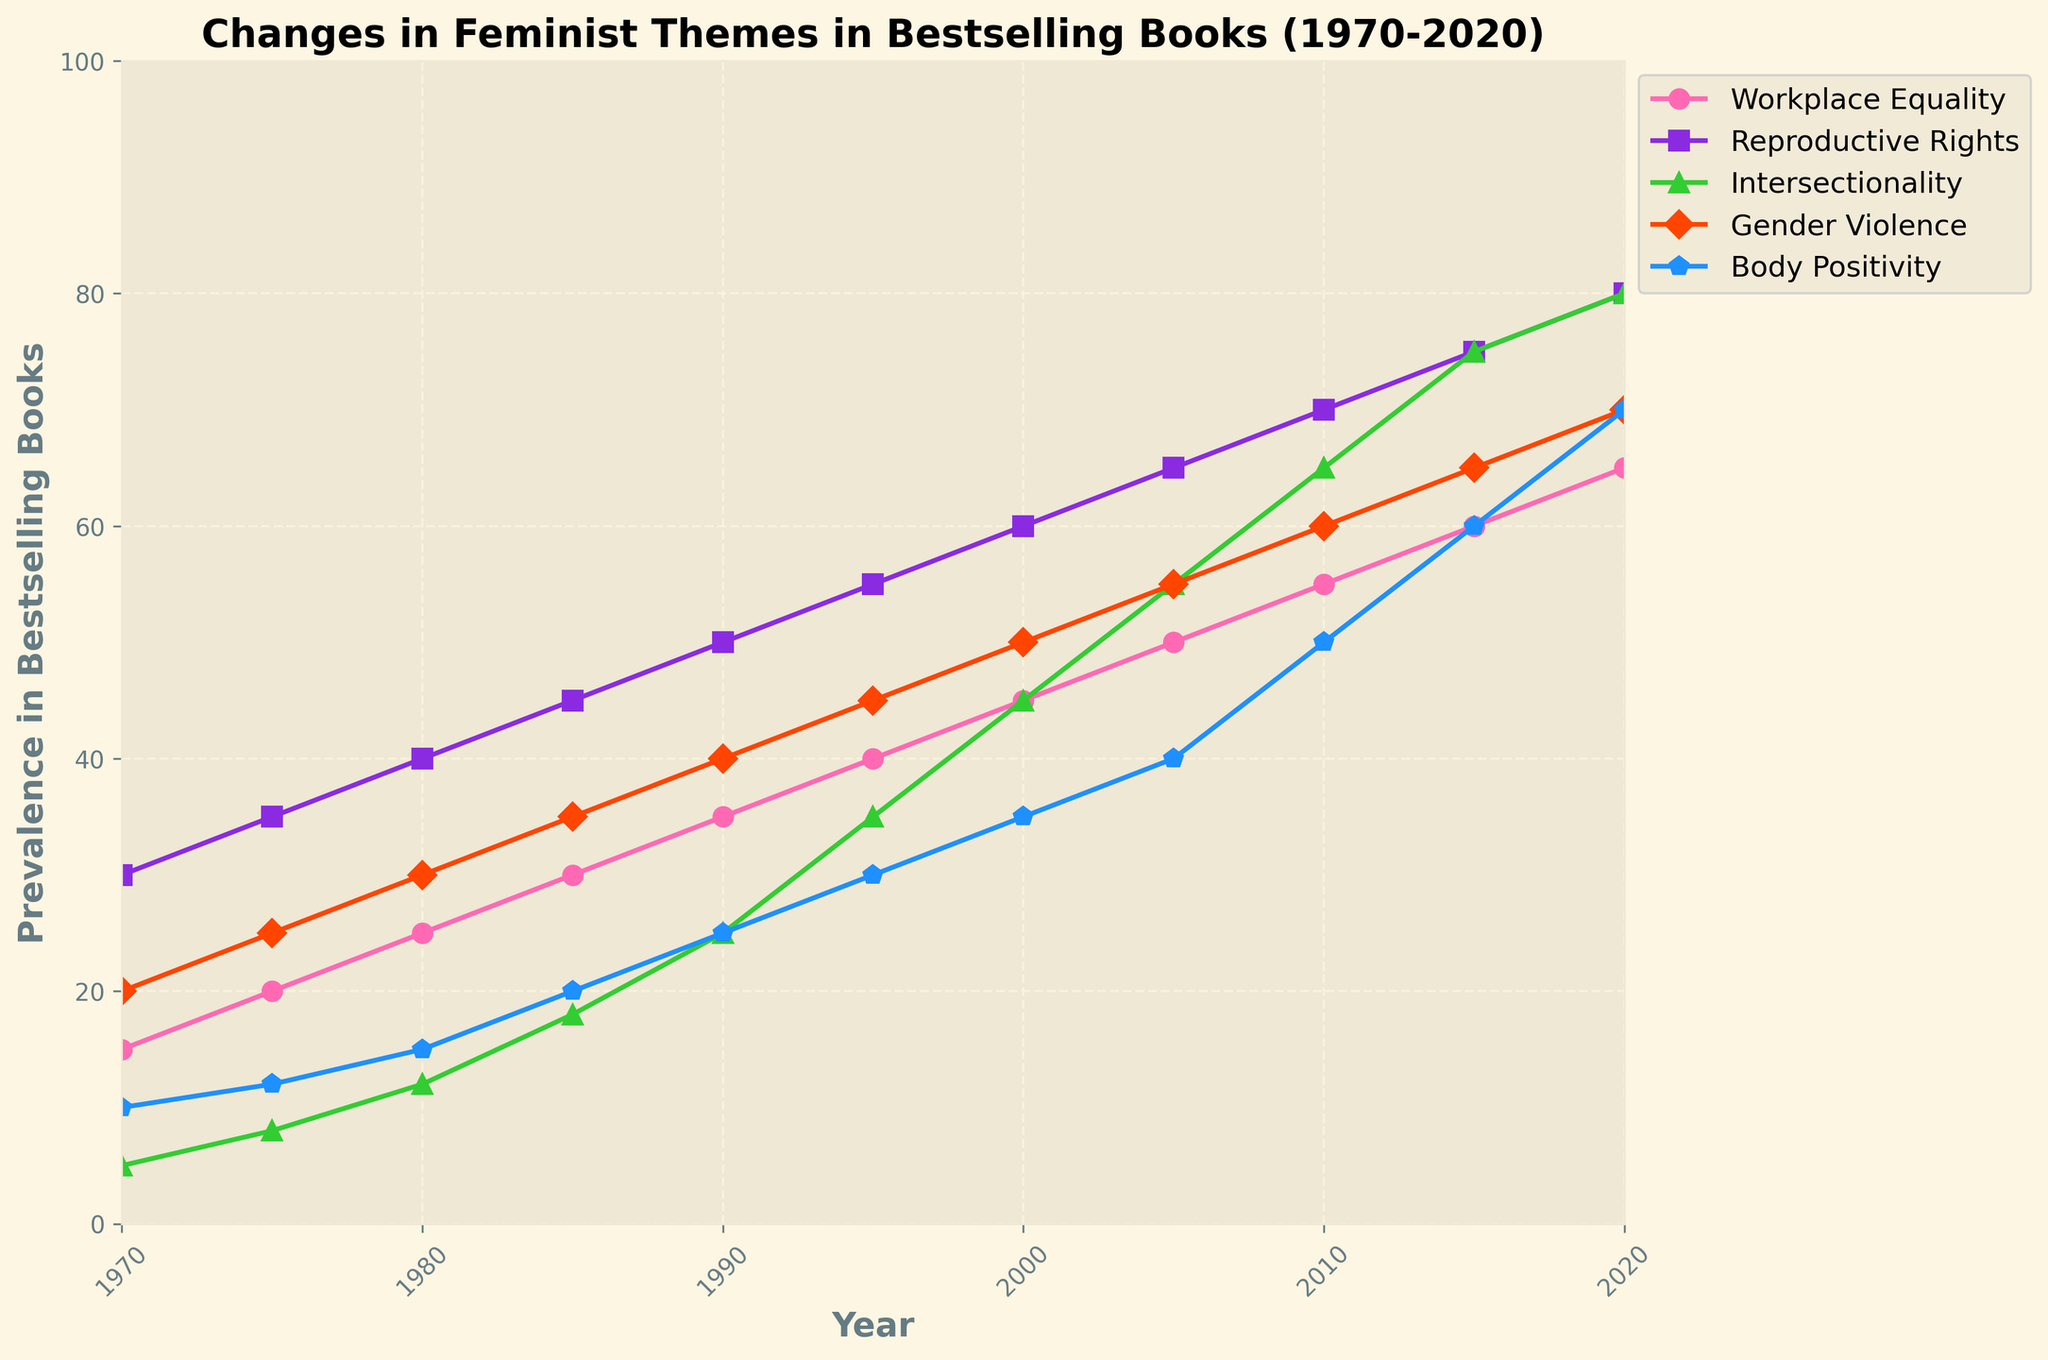What was the prevalence of Reproductive Rights in 1980 compared to Gender Violence in the same year? First, identify the value of Reproductive Rights in 1980, which is 40. Then, identify the value of Gender Violence in 1980, which is 30. Comparing the values, Reproductive Rights have a higher prevalence.
Answer: Reproductive Rights: 40, Gender Violence: 30 Which theme had the highest prevalence in 2020? Look at the data points for each theme in 2020. Workplace Equality: 65, Reproductive Rights: 80, Intersectionality: 80, Gender Violence: 70, Body Positivity: 70. Both Reproductive Rights and Intersectionality had the highest prevalence at 80.
Answer: Reproductive Rights and Intersectionality Between 1995 and 2000, which theme had the largest increase in prevalence? First, calculate the increase for each theme from 1995 to 2000:
- Workplace Equality: 45 - 40 = 5
- Reproductive Rights: 60 - 55 = 5
- Intersectionality: 45 - 35 = 10
- Gender Violence: 50 - 45 = 5
- Body Positivity: 35 - 30 = 5
Intersectionality had the largest increase, which is 10.
Answer: Intersectionality What was the average prevalence of Body Positivity over the span of these 50 years? Sum the Body Positivity values: 10 + 12 + 15 + 20 + 25 + 30 + 35 + 40 + 50 + 60 + 70 = 367. There are 11 data points (50 years in 5-year intervals). So, the average is 367 / 11 = 33.36
Answer: 33.36 Which theme saw the smallest change in prevalence between 1970 and 2020? Calculate the change for each theme between 1970 and 2020:
- Workplace Equality: 65 - 15 = 50
- Reproductive Rights: 80 - 30 = 50
- Intersectionality: 80 - 5 = 75
- Gender Violence: 70 - 20 = 50
- Body Positivity: 70 - 10 = 60
The smallest change is 50, shared by Workplace Equality, Reproductive Rights, and Gender Violence.
Answer: Workplace Equality, Reproductive Rights, and Gender Violence How does the trend of Intersectionality compare to Body Positivity from 1990 to 2020? From 1990 to 2020, Intersectionality's prevalence increased from 25 to 80 (an increase of 55), while Body Positivity's prevalence increased from 25 to 70 (an increase of 45). Therefore, Intersectionality shows a steeper upward trend compared to Body Positivity.
Answer: Intersectionality shows a steeper upward trend What is the median value for Gender Violence across the five-decade span? List Gender Violence values: 20, 25, 30, 35, 40, 45, 50, 55, 60, 65, 70. Arrange in order (it's already sorted). The median is the value at the middle position, which is the 6th value: 45.
Answer: 45 By how much did the prevalence of Workplace Equality increase from 1970 to 1990? Calculate the increase: Workplace Equality in 1990 is 35 and in 1970 is 15. So, 35 - 15 = 20.
Answer: 20 